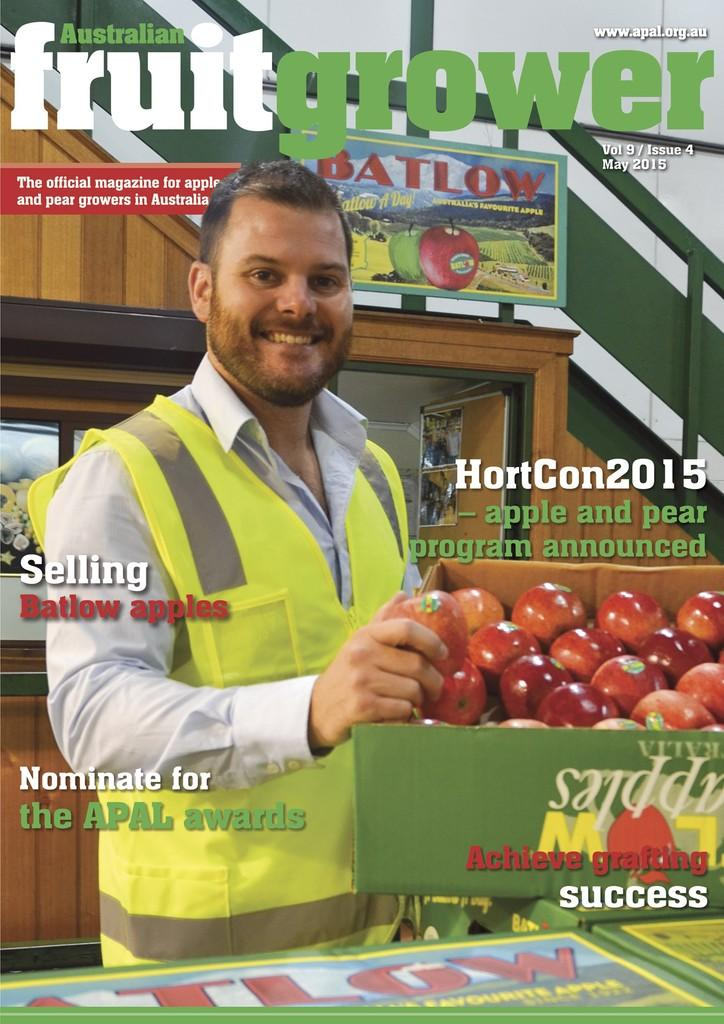Who is the main subject in the image? There is a guy in the image. What is the guy doing in the image? The guy is selling apples. How are the apples being displayed or stored? The apples are in a basket. What can be seen besides the guy and the apples? There is a magazine in the image. What is the title of the magazine? The magazine has "Australian fruit grower" written on it. What type of mailbox is visible in the image? There is no mailbox present in the image. What is the guy's facial expression while selling apples? The provided facts do not mention the guy's facial expression, so it cannot be determined from the image. 